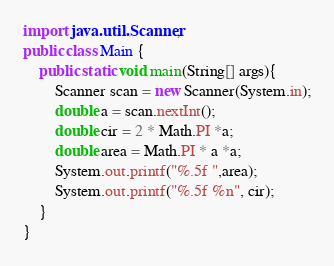<code> <loc_0><loc_0><loc_500><loc_500><_Java_>import java.util.Scanner;
public class Main {
    public static void main(String[] args){
        Scanner scan = new Scanner(System.in);
        double a = scan.nextInt();
        double cir = 2 * Math.PI *a;
        double area = Math.PI * a *a;
        System.out.printf("%.5f ",area);
        System.out.printf("%.5f %n", cir);
    }
}
</code> 